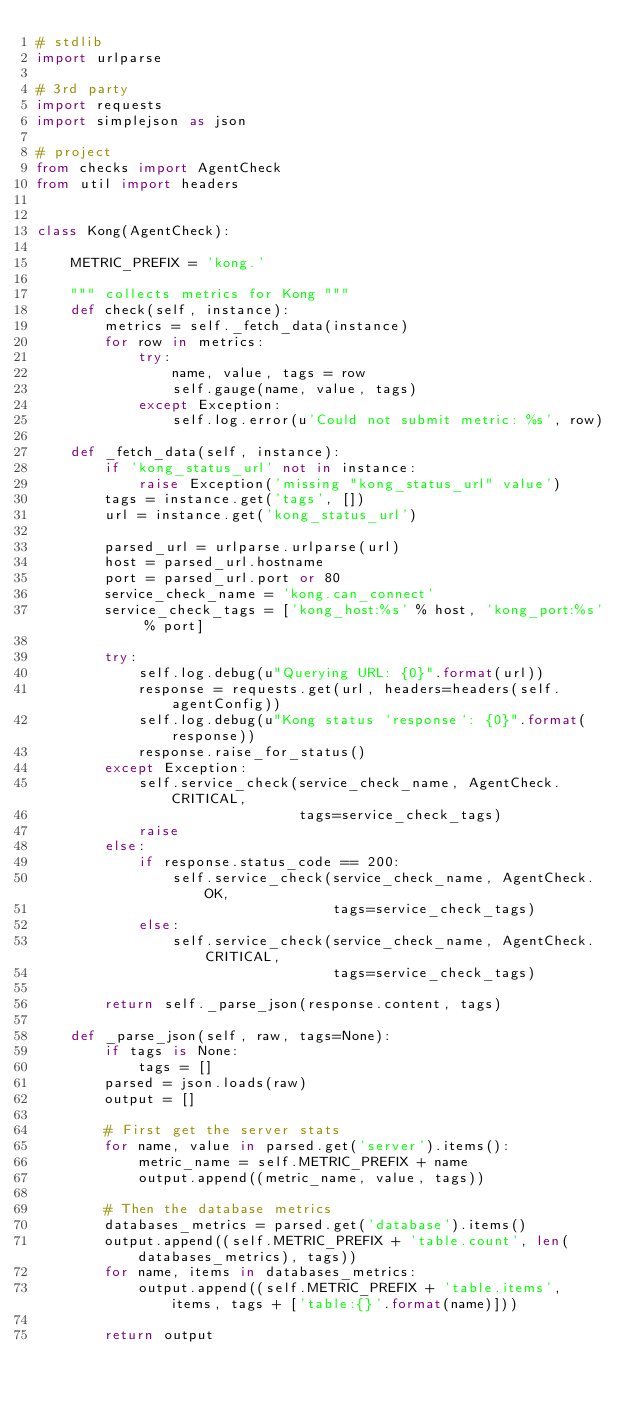<code> <loc_0><loc_0><loc_500><loc_500><_Python_># stdlib
import urlparse

# 3rd party
import requests
import simplejson as json

# project
from checks import AgentCheck
from util import headers


class Kong(AgentCheck):

    METRIC_PREFIX = 'kong.'

    """ collects metrics for Kong """
    def check(self, instance):
        metrics = self._fetch_data(instance)
        for row in metrics:
            try:
                name, value, tags = row
                self.gauge(name, value, tags)
            except Exception:
                self.log.error(u'Could not submit metric: %s', row)

    def _fetch_data(self, instance):
        if 'kong_status_url' not in instance:
            raise Exception('missing "kong_status_url" value')
        tags = instance.get('tags', [])
        url = instance.get('kong_status_url')

        parsed_url = urlparse.urlparse(url)
        host = parsed_url.hostname
        port = parsed_url.port or 80
        service_check_name = 'kong.can_connect'
        service_check_tags = ['kong_host:%s' % host, 'kong_port:%s' % port]

        try:
            self.log.debug(u"Querying URL: {0}".format(url))
            response = requests.get(url, headers=headers(self.agentConfig))
            self.log.debug(u"Kong status `response`: {0}".format(response))
            response.raise_for_status()
        except Exception:
            self.service_check(service_check_name, AgentCheck.CRITICAL,
                               tags=service_check_tags)
            raise
        else:
            if response.status_code == 200:
                self.service_check(service_check_name, AgentCheck.OK,
                                   tags=service_check_tags)
            else:
                self.service_check(service_check_name, AgentCheck.CRITICAL,
                                   tags=service_check_tags)

        return self._parse_json(response.content, tags)

    def _parse_json(self, raw, tags=None):
        if tags is None:
            tags = []
        parsed = json.loads(raw)
        output = []

        # First get the server stats
        for name, value in parsed.get('server').items():
            metric_name = self.METRIC_PREFIX + name
            output.append((metric_name, value, tags))

        # Then the database metrics
        databases_metrics = parsed.get('database').items()
        output.append((self.METRIC_PREFIX + 'table.count', len(databases_metrics), tags))
        for name, items in databases_metrics:
            output.append((self.METRIC_PREFIX + 'table.items', items, tags + ['table:{}'.format(name)]))

        return output
</code> 